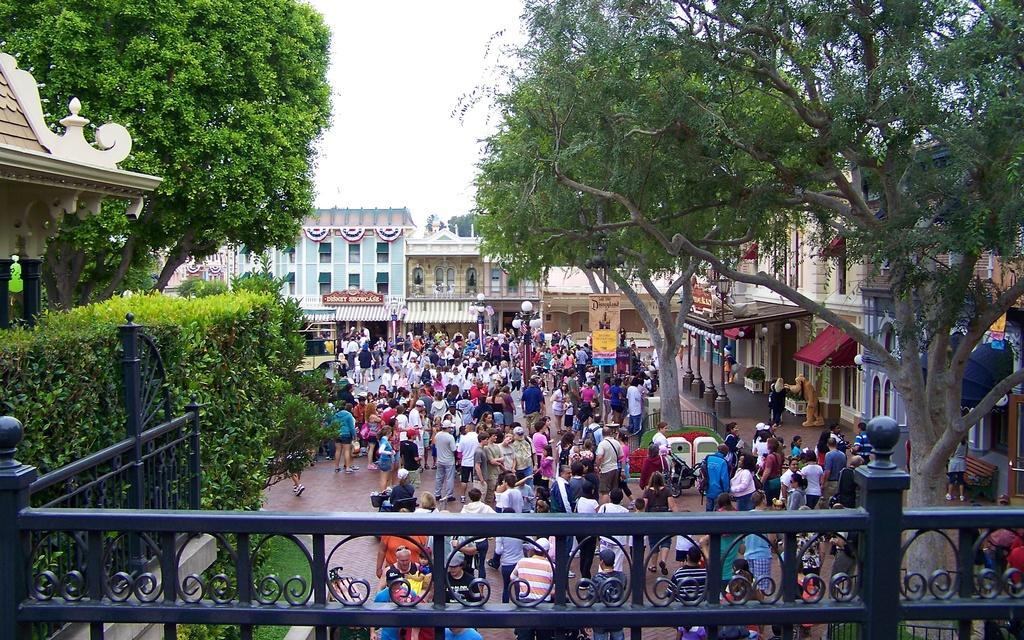In one or two sentences, can you explain what this image depicts? In the middle a group of people are there and on the back side there are houses. These are the green color trees. 